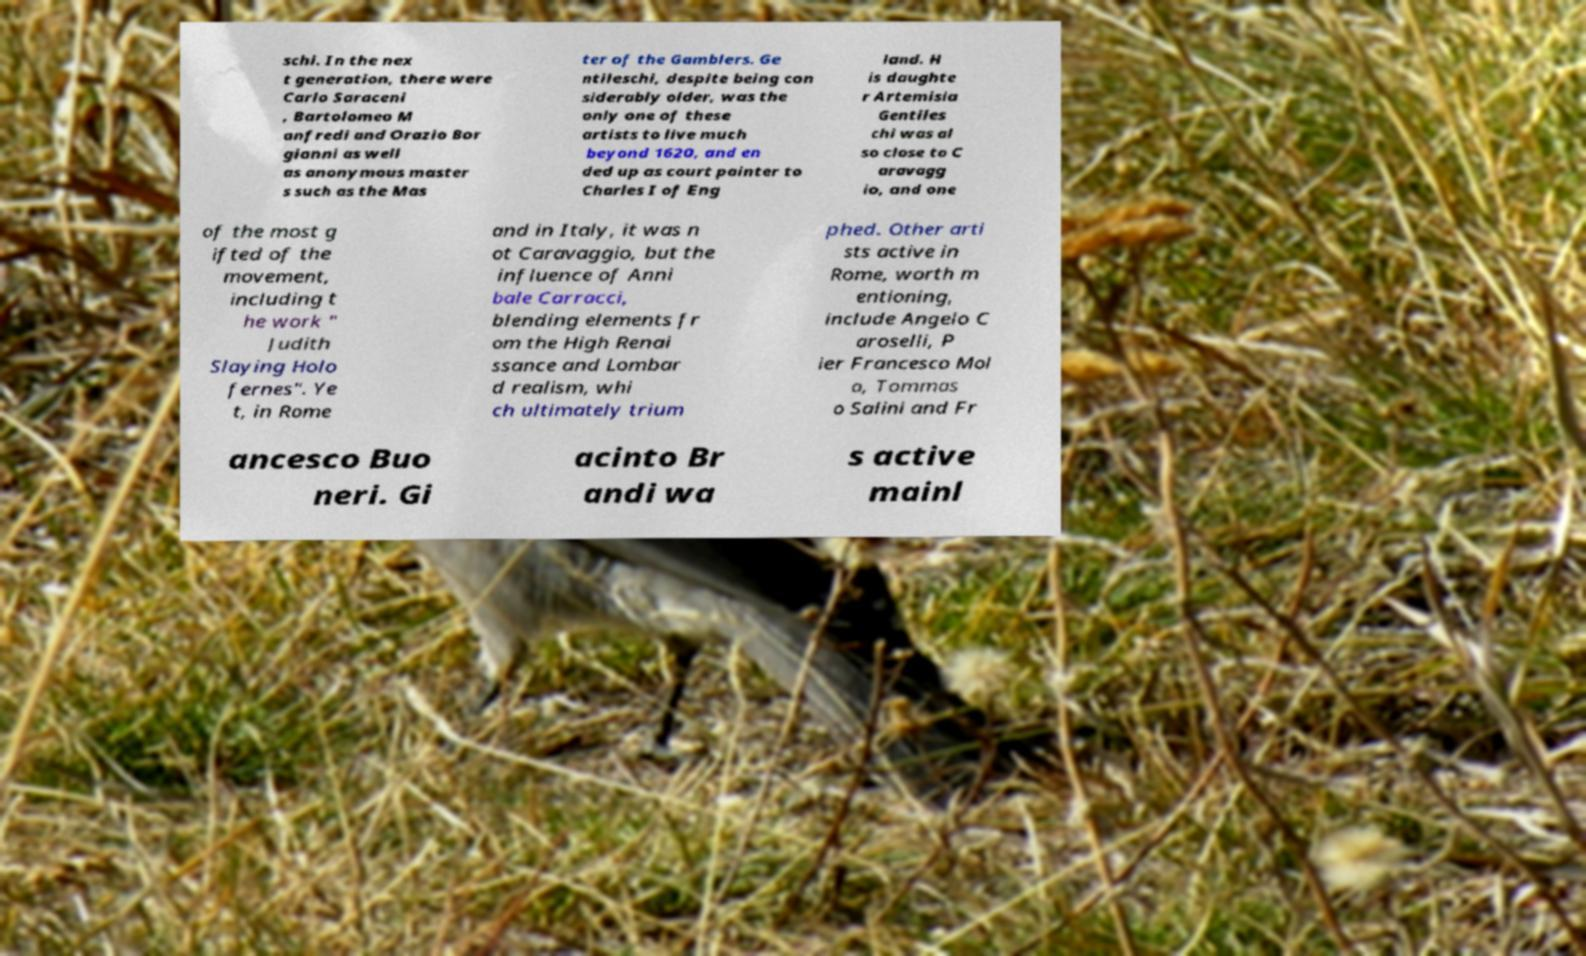For documentation purposes, I need the text within this image transcribed. Could you provide that? schi. In the nex t generation, there were Carlo Saraceni , Bartolomeo M anfredi and Orazio Bor gianni as well as anonymous master s such as the Mas ter of the Gamblers. Ge ntileschi, despite being con siderably older, was the only one of these artists to live much beyond 1620, and en ded up as court painter to Charles I of Eng land. H is daughte r Artemisia Gentiles chi was al so close to C aravagg io, and one of the most g ifted of the movement, including t he work " Judith Slaying Holo fernes". Ye t, in Rome and in Italy, it was n ot Caravaggio, but the influence of Anni bale Carracci, blending elements fr om the High Renai ssance and Lombar d realism, whi ch ultimately trium phed. Other arti sts active in Rome, worth m entioning, include Angelo C aroselli, P ier Francesco Mol a, Tommas o Salini and Fr ancesco Buo neri. Gi acinto Br andi wa s active mainl 